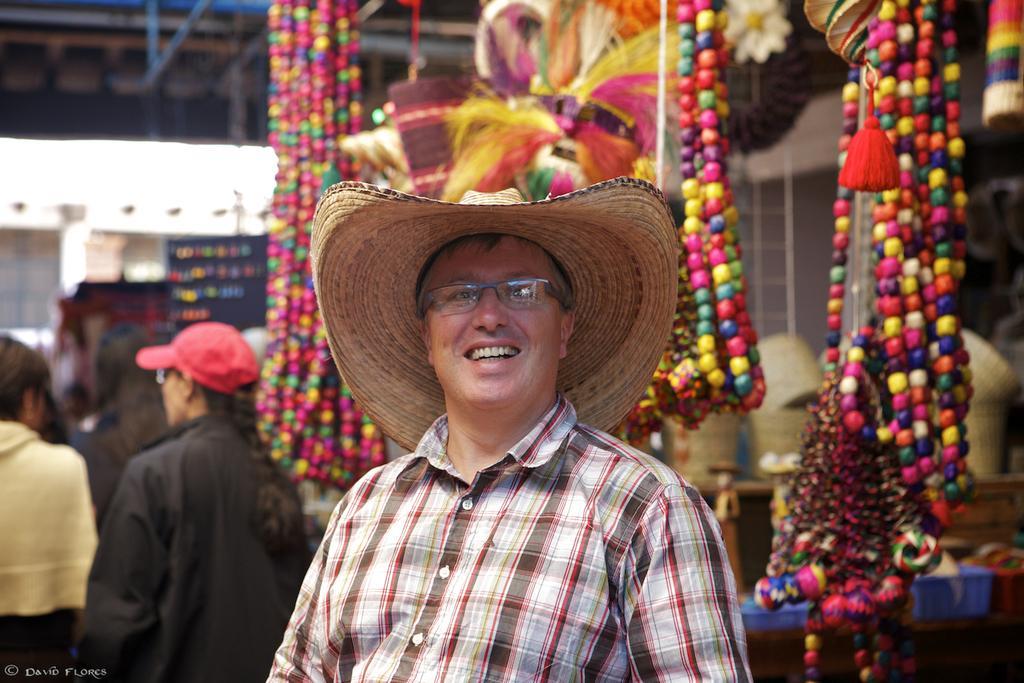Can you describe this image briefly? This is the man standing and smiling. He wore a hat. These are the colorful beads. On the left side of the image, I can see two people standing. In the background, I can see few objects. At the bottom left side of the image, this is the watermark. 